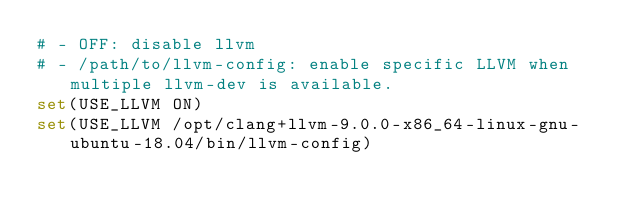Convert code to text. <code><loc_0><loc_0><loc_500><loc_500><_CMake_># - OFF: disable llvm
# - /path/to/llvm-config: enable specific LLVM when multiple llvm-dev is available.
set(USE_LLVM ON)
set(USE_LLVM /opt/clang+llvm-9.0.0-x86_64-linux-gnu-ubuntu-18.04/bin/llvm-config)</code> 